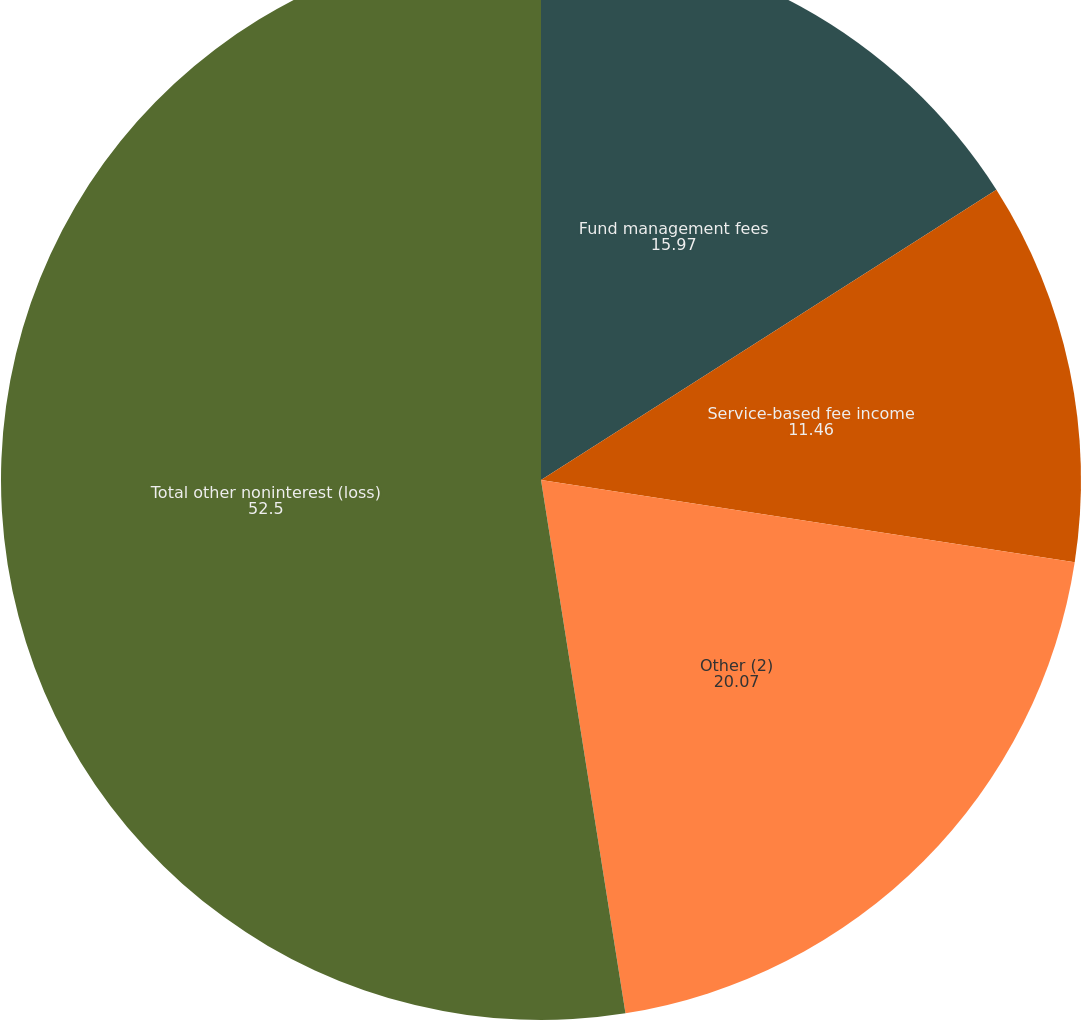Convert chart to OTSL. <chart><loc_0><loc_0><loc_500><loc_500><pie_chart><fcel>Fund management fees<fcel>Service-based fee income<fcel>Other (2)<fcel>Total other noninterest (loss)<nl><fcel>15.97%<fcel>11.46%<fcel>20.07%<fcel>52.5%<nl></chart> 